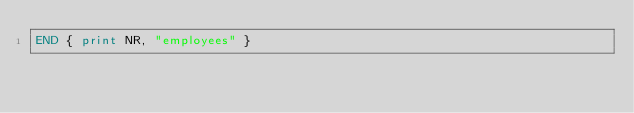<code> <loc_0><loc_0><loc_500><loc_500><_Awk_>END { print NR, "employees" }
</code> 